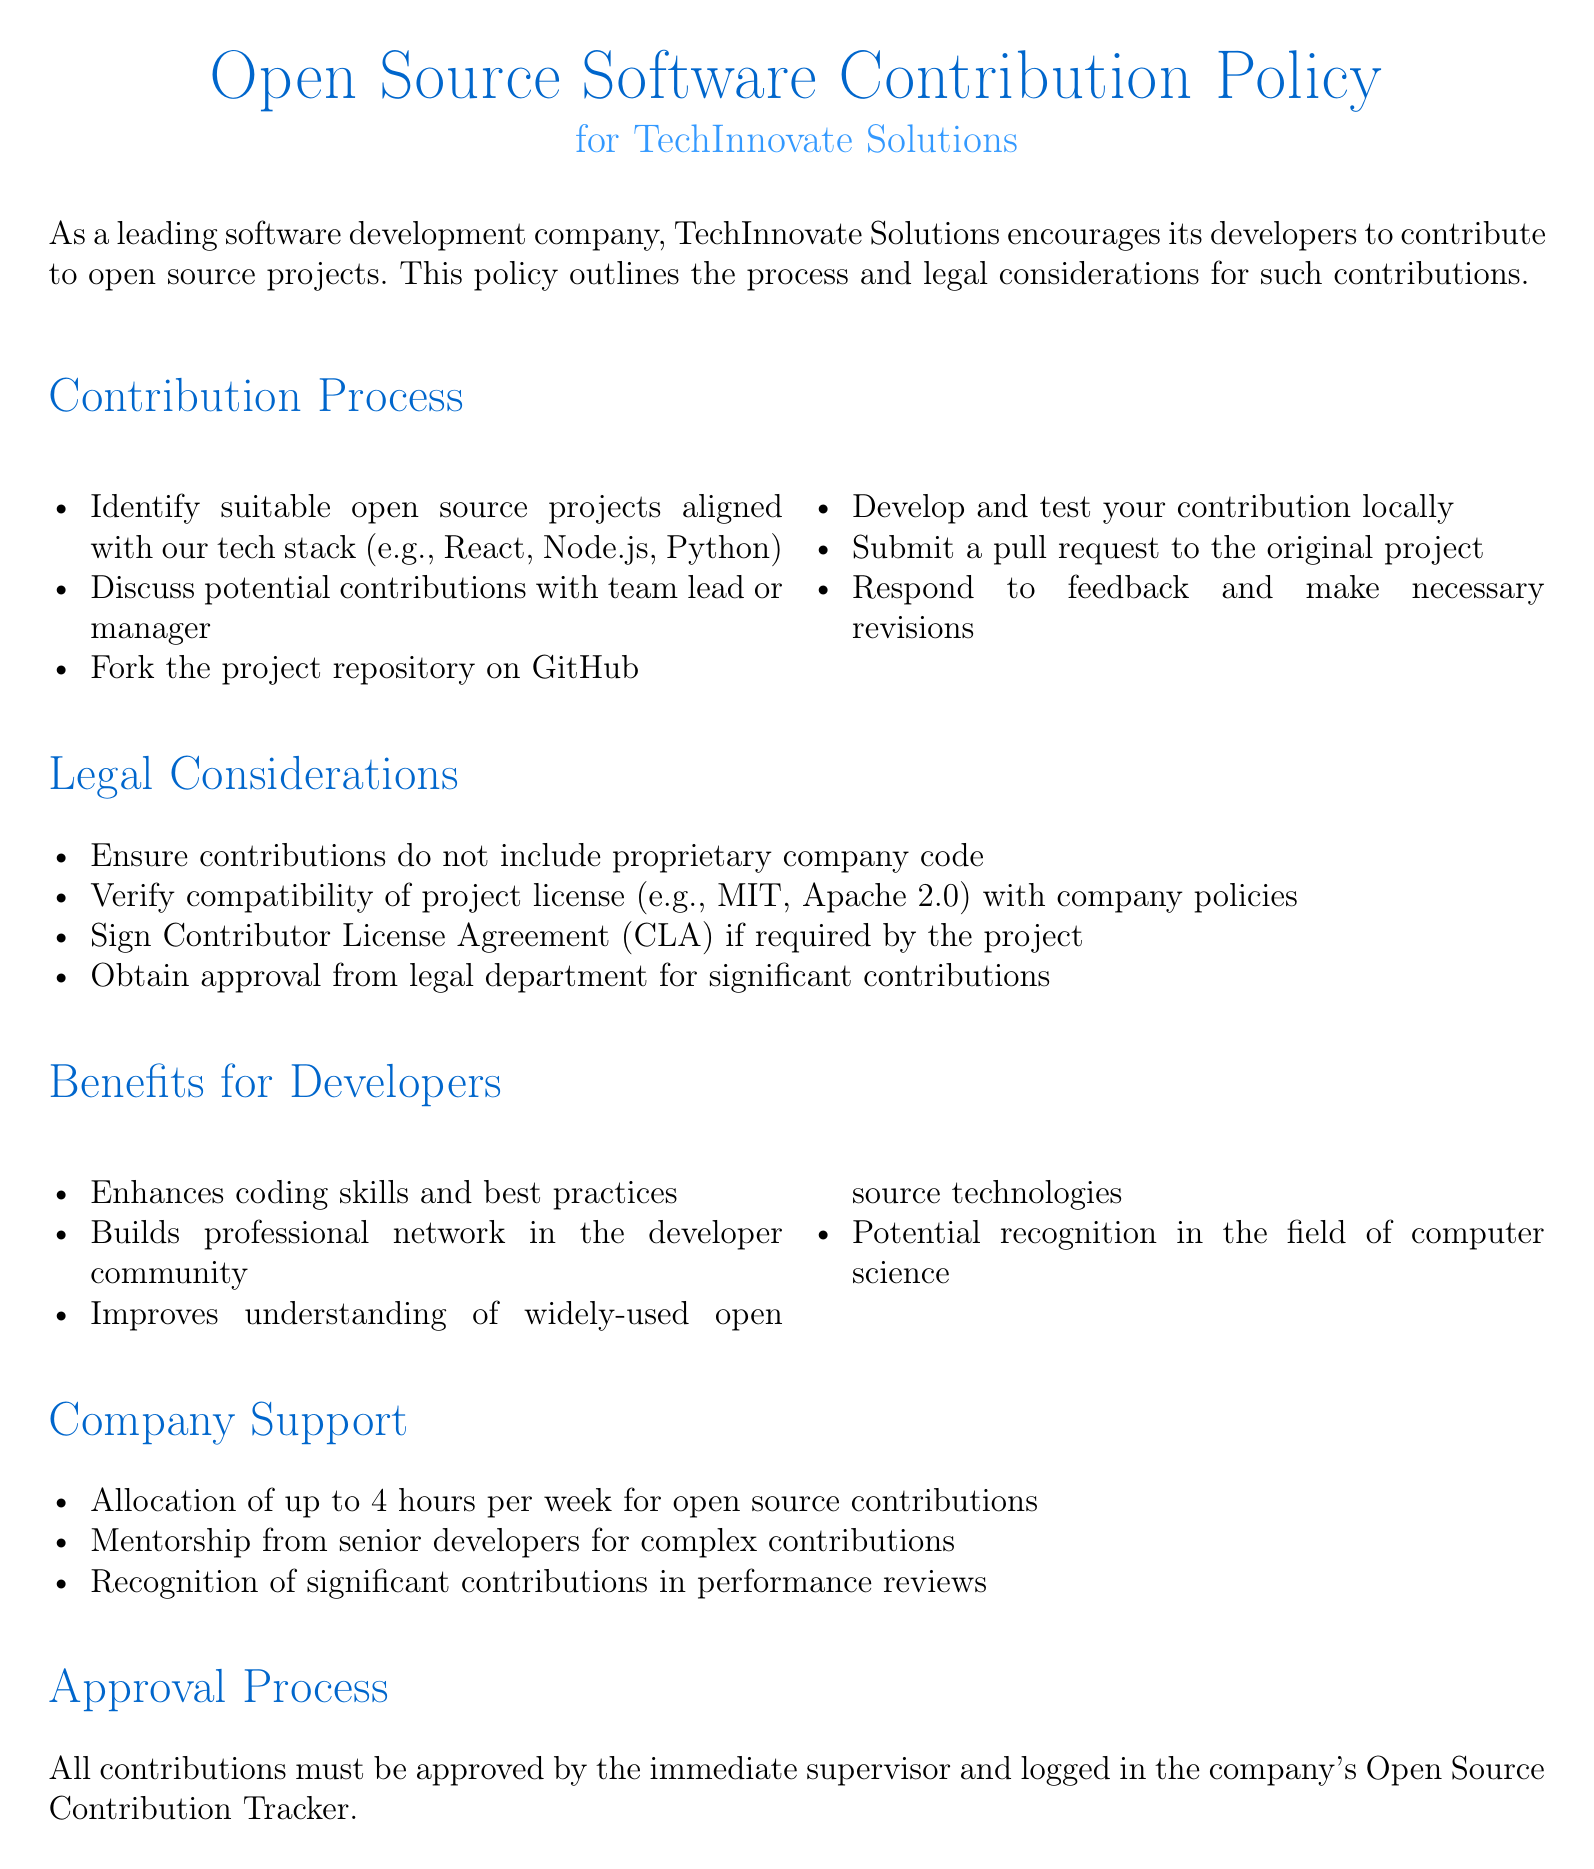What is the title of the policy document? The title of the policy document is stated at the beginning, identifying it clearly.
Answer: Open Source Software Contribution Policy Who is the policy for? The document specifically mentions the organization that the policy is meant for.
Answer: TechInnovate Solutions How many hours per week can developers allocate for open source contributions? The document specifies a limit on the time that can be dedicated to contributions.
Answer: 4 hours What is the first step in the contribution process? The document outlines a sequence of steps and provides details about the initial action to be taken.
Answer: Identify suitable open source projects What must be verified regarding the project license? The policy outlines a legal consideration that developers must take into account before contributing.
Answer: Compatibility with company policies What must contributors sign if required by the project? A specific legal action is mentioned in relation to the contributions.
Answer: Contributor License Agreement (CLA) What type of mentorship is provided for contributions? The document describes support from the company during the contribution process.
Answer: Mentorship from senior developers What is required after submitting a pull request? The document indicates a responsibility that developers have post-submission of their contributions.
Answer: Respond to feedback What kind of recognition is mentioned in the document? The document states a form of acknowledgment that developers can receive as a result of their contributions.
Answer: Recognition of significant contributions in performance reviews 